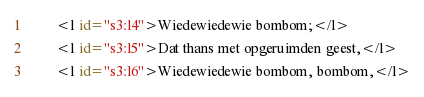Convert code to text. <code><loc_0><loc_0><loc_500><loc_500><_XML_>        <l id="s3:l4">Wiedewiedewie bombom;</l>
        <l id="s3:l5">Dat thans met opgeruimden geest,</l>
        <l id="s3:l6">Wiedewiedewie bombom, bombom,</l></code> 